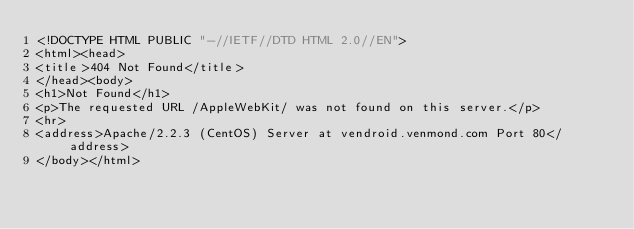<code> <loc_0><loc_0><loc_500><loc_500><_HTML_><!DOCTYPE HTML PUBLIC "-//IETF//DTD HTML 2.0//EN">
<html><head>
<title>404 Not Found</title>
</head><body>
<h1>Not Found</h1>
<p>The requested URL /AppleWebKit/ was not found on this server.</p>
<hr>
<address>Apache/2.2.3 (CentOS) Server at vendroid.venmond.com Port 80</address>
</body></html>
</code> 